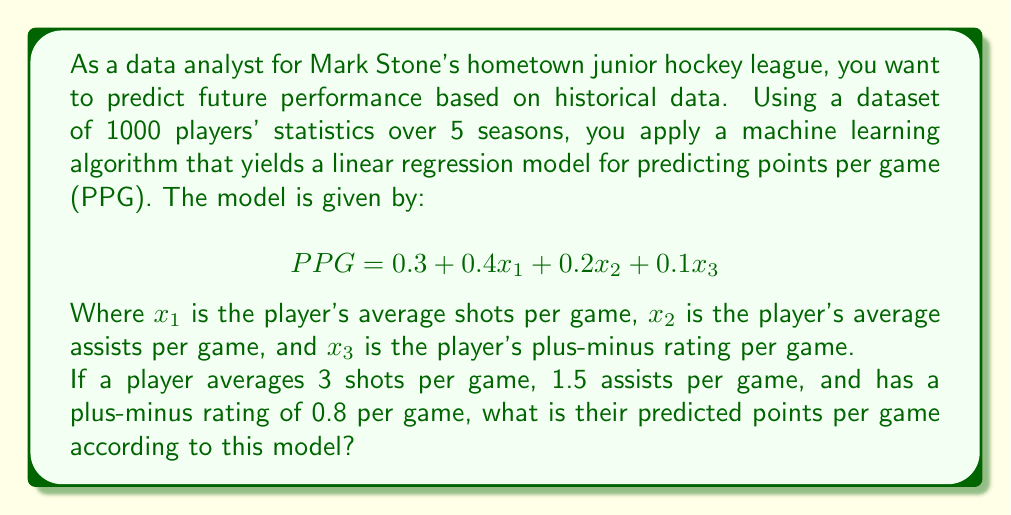Can you answer this question? To solve this problem, we need to follow these steps:

1) Identify the given information:
   - The linear regression model: $PPG = 0.3 + 0.4x_1 + 0.2x_2 + 0.1x_3$
   - $x_1$ (average shots per game) = 3
   - $x_2$ (average assists per game) = 1.5
   - $x_3$ (plus-minus rating per game) = 0.8

2) Substitute these values into the equation:

   $PPG = 0.3 + 0.4(3) + 0.2(1.5) + 0.1(0.8)$

3) Solve the equation step by step:

   $PPG = 0.3 + 1.2 + 0.3 + 0.08$

   $PPG = 1.88$

Therefore, according to this model, a player with these statistics is predicted to score 1.88 points per game.
Answer: 1.88 points per game 